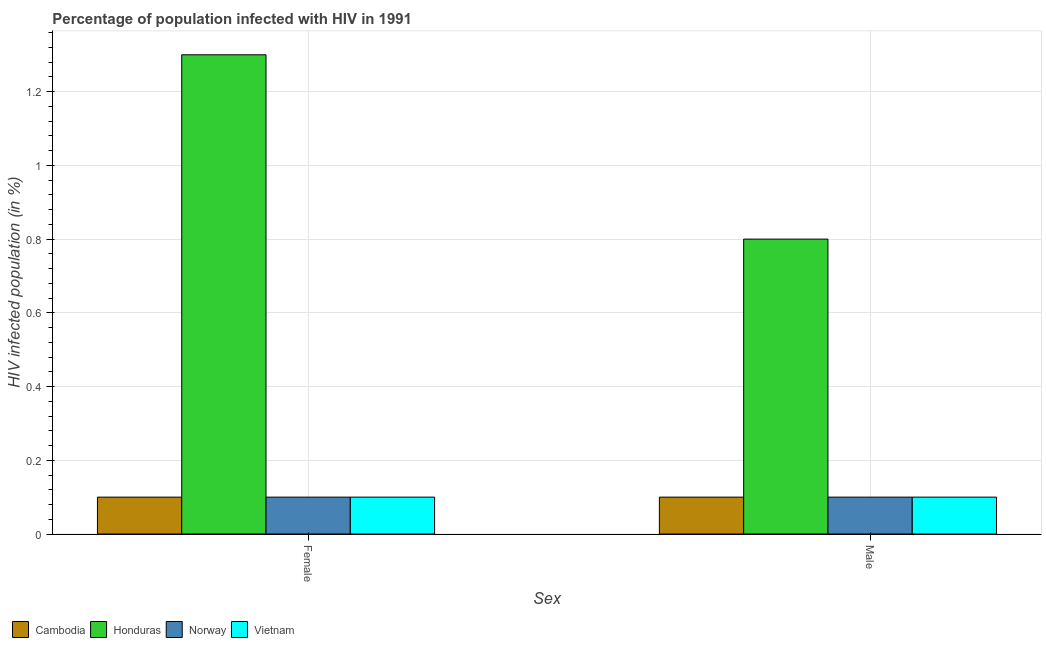How many groups of bars are there?
Provide a succinct answer. 2. Are the number of bars on each tick of the X-axis equal?
Offer a very short reply. Yes. How many bars are there on the 2nd tick from the right?
Offer a terse response. 4. What is the label of the 1st group of bars from the left?
Offer a terse response. Female. What is the percentage of females who are infected with hiv in Vietnam?
Your response must be concise. 0.1. In which country was the percentage of males who are infected with hiv maximum?
Offer a terse response. Honduras. In which country was the percentage of females who are infected with hiv minimum?
Give a very brief answer. Cambodia. What is the total percentage of females who are infected with hiv in the graph?
Your response must be concise. 1.6. What is the difference between the percentage of males who are infected with hiv in Cambodia and that in Honduras?
Provide a short and direct response. -0.7. What is the average percentage of males who are infected with hiv per country?
Your answer should be compact. 0.28. What is the ratio of the percentage of females who are infected with hiv in Cambodia to that in Honduras?
Offer a very short reply. 0.08. Is the percentage of males who are infected with hiv in Norway less than that in Cambodia?
Provide a succinct answer. No. In how many countries, is the percentage of males who are infected with hiv greater than the average percentage of males who are infected with hiv taken over all countries?
Make the answer very short. 1. What does the 3rd bar from the left in Male represents?
Keep it short and to the point. Norway. What does the 1st bar from the right in Male represents?
Your answer should be very brief. Vietnam. Are all the bars in the graph horizontal?
Offer a terse response. No. What is the difference between two consecutive major ticks on the Y-axis?
Make the answer very short. 0.2. Are the values on the major ticks of Y-axis written in scientific E-notation?
Your answer should be compact. No. Does the graph contain any zero values?
Give a very brief answer. No. Does the graph contain grids?
Your response must be concise. Yes. What is the title of the graph?
Keep it short and to the point. Percentage of population infected with HIV in 1991. What is the label or title of the X-axis?
Your response must be concise. Sex. What is the label or title of the Y-axis?
Ensure brevity in your answer.  HIV infected population (in %). What is the HIV infected population (in %) in Cambodia in Female?
Your answer should be very brief. 0.1. What is the HIV infected population (in %) in Norway in Female?
Your response must be concise. 0.1. What is the HIV infected population (in %) of Vietnam in Female?
Your response must be concise. 0.1. What is the HIV infected population (in %) in Cambodia in Male?
Ensure brevity in your answer.  0.1. What is the HIV infected population (in %) of Honduras in Male?
Your response must be concise. 0.8. What is the HIV infected population (in %) of Norway in Male?
Provide a succinct answer. 0.1. What is the HIV infected population (in %) of Vietnam in Male?
Your answer should be compact. 0.1. Across all Sex, what is the maximum HIV infected population (in %) of Cambodia?
Offer a very short reply. 0.1. Across all Sex, what is the maximum HIV infected population (in %) in Vietnam?
Offer a very short reply. 0.1. Across all Sex, what is the minimum HIV infected population (in %) in Cambodia?
Give a very brief answer. 0.1. What is the total HIV infected population (in %) in Cambodia in the graph?
Offer a very short reply. 0.2. What is the total HIV infected population (in %) in Norway in the graph?
Give a very brief answer. 0.2. What is the total HIV infected population (in %) of Vietnam in the graph?
Make the answer very short. 0.2. What is the difference between the HIV infected population (in %) of Honduras in Female and that in Male?
Keep it short and to the point. 0.5. What is the difference between the HIV infected population (in %) in Norway in Female and that in Male?
Provide a succinct answer. 0. What is the difference between the HIV infected population (in %) of Cambodia in Female and the HIV infected population (in %) of Honduras in Male?
Your response must be concise. -0.7. What is the difference between the HIV infected population (in %) of Cambodia in Female and the HIV infected population (in %) of Norway in Male?
Your answer should be very brief. 0. What is the difference between the HIV infected population (in %) of Honduras in Female and the HIV infected population (in %) of Vietnam in Male?
Your answer should be very brief. 1.2. What is the average HIV infected population (in %) in Cambodia per Sex?
Keep it short and to the point. 0.1. What is the average HIV infected population (in %) of Honduras per Sex?
Your answer should be compact. 1.05. What is the average HIV infected population (in %) in Norway per Sex?
Provide a succinct answer. 0.1. What is the average HIV infected population (in %) of Vietnam per Sex?
Ensure brevity in your answer.  0.1. What is the difference between the HIV infected population (in %) in Cambodia and HIV infected population (in %) in Honduras in Female?
Your response must be concise. -1.2. What is the difference between the HIV infected population (in %) of Cambodia and HIV infected population (in %) of Norway in Female?
Offer a terse response. 0. What is the difference between the HIV infected population (in %) in Honduras and HIV infected population (in %) in Vietnam in Female?
Ensure brevity in your answer.  1.2. What is the difference between the HIV infected population (in %) of Cambodia and HIV infected population (in %) of Honduras in Male?
Your response must be concise. -0.7. What is the difference between the HIV infected population (in %) in Honduras and HIV infected population (in %) in Norway in Male?
Your response must be concise. 0.7. What is the difference between the HIV infected population (in %) of Honduras and HIV infected population (in %) of Vietnam in Male?
Your answer should be very brief. 0.7. What is the ratio of the HIV infected population (in %) of Cambodia in Female to that in Male?
Give a very brief answer. 1. What is the ratio of the HIV infected population (in %) in Honduras in Female to that in Male?
Keep it short and to the point. 1.62. What is the difference between the highest and the second highest HIV infected population (in %) in Cambodia?
Provide a succinct answer. 0. What is the difference between the highest and the second highest HIV infected population (in %) of Honduras?
Give a very brief answer. 0.5. What is the difference between the highest and the second highest HIV infected population (in %) in Vietnam?
Keep it short and to the point. 0. What is the difference between the highest and the lowest HIV infected population (in %) of Cambodia?
Offer a terse response. 0. What is the difference between the highest and the lowest HIV infected population (in %) in Honduras?
Keep it short and to the point. 0.5. What is the difference between the highest and the lowest HIV infected population (in %) in Norway?
Your response must be concise. 0. 